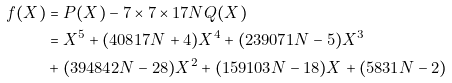Convert formula to latex. <formula><loc_0><loc_0><loc_500><loc_500>f ( X ) & = P ( X ) - 7 \times 7 \times 1 7 N Q ( X ) \\ & = X ^ { 5 } + ( 4 0 8 1 7 N + 4 ) X ^ { 4 } + ( 2 3 9 0 7 1 N - 5 ) X ^ { 3 } \\ & + ( 3 9 4 8 4 2 N - 2 8 ) X ^ { 2 } + ( 1 5 9 1 0 3 N - 1 8 ) X + ( 5 8 3 1 N - 2 )</formula> 